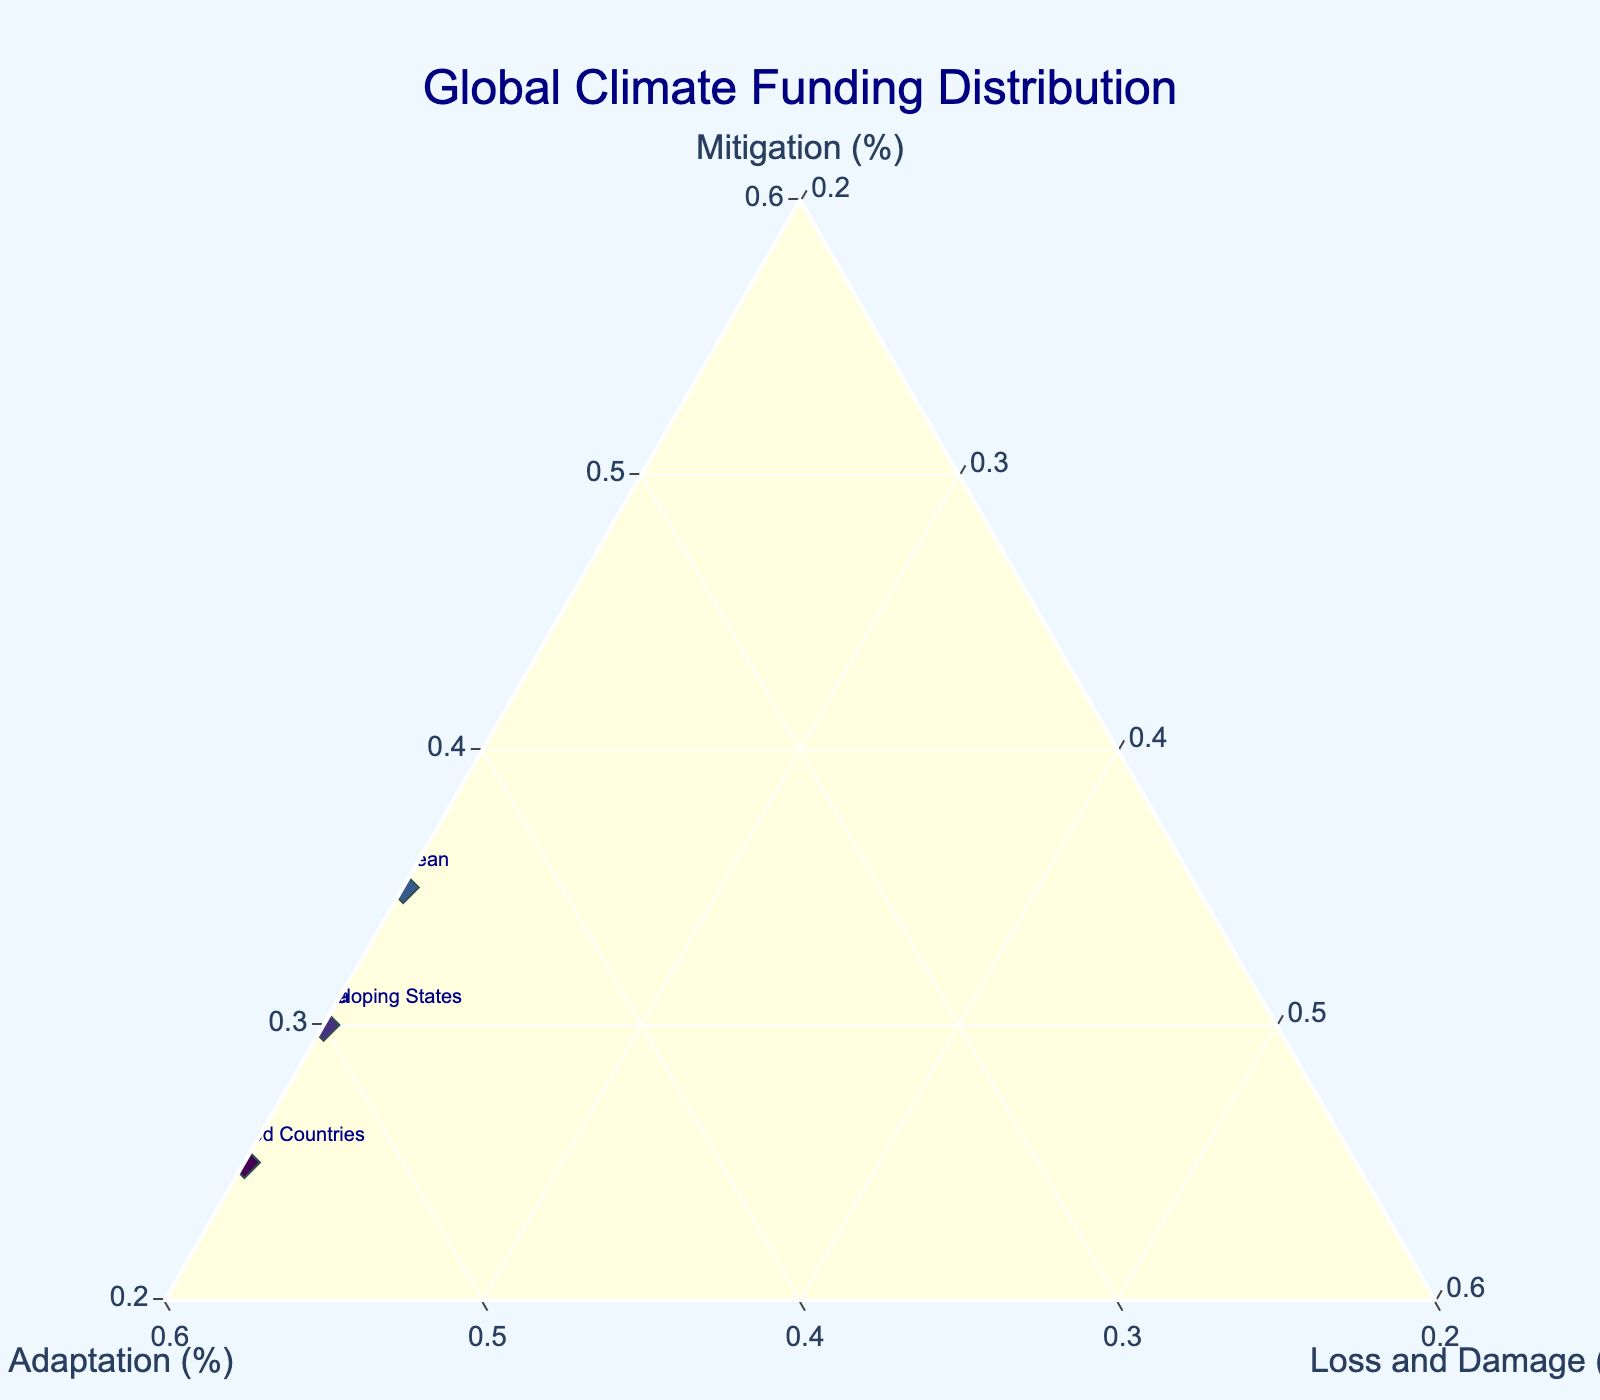What's the title of the figure? The title is displayed prominently at the top of the Ternary Plot.
Answer: Global Climate Funding Distribution How many regions are represented in the plot? By counting the data points labeled with region names, we get the number of regions represented.
Answer: 10 Which region allocates the highest percentage of funding to mitigation? By looking at the a-axis (Mitigation) values, identify the region with the highest percentage.
Answer: North America What region has the highest percentage allocated to adaptation? By comparing the b-axis (Adaptation) values, determine the region with the highest percentage.
Answer: Least Developed Countries For the Caribbean, what are the allocations for mitigation, adaptation, and loss & damage, respectively? Locate the point labeled Caribbean and note the values for the three components.
Answer: 35, 45, 20 Which regions allocate the same percentage to loss and damage? By comparing the c-axis (Loss and Damage) values, identify the regions with the same percentage.
Answer: North America, Europe, and Asia Pacific How does the distribution of funding in Africa compare to that in Europe in terms of adaptation? Look at the b-axis (Adaptation) values for both Africa and Europe and compare.
Answer: Africa allocates more to adaptation (50% vs 35%) What is the average percentage of funding allocated to mitigation across all regions? Sum all the Mitigation values and divide by the number of regions.
Answer: (60 + 55 + 50 + 30 + 40 + 45 + 35 + 50 + 25 + 30) / 10 = 42 Which two regions allocate the highest combined percentage to loss and damage? Add the percentages for Loss and Damage for all regions and identify the pair with the highest sum.
Answer: Africa and Caribbean (20 + 20 = 40) What percentage of funding is allocated to adaptation and loss & damage combined for the Small Island Developing States? Add the Adaptation and Loss and Damage values for Small Island Developing States.
Answer: 50 + 20 = 70 